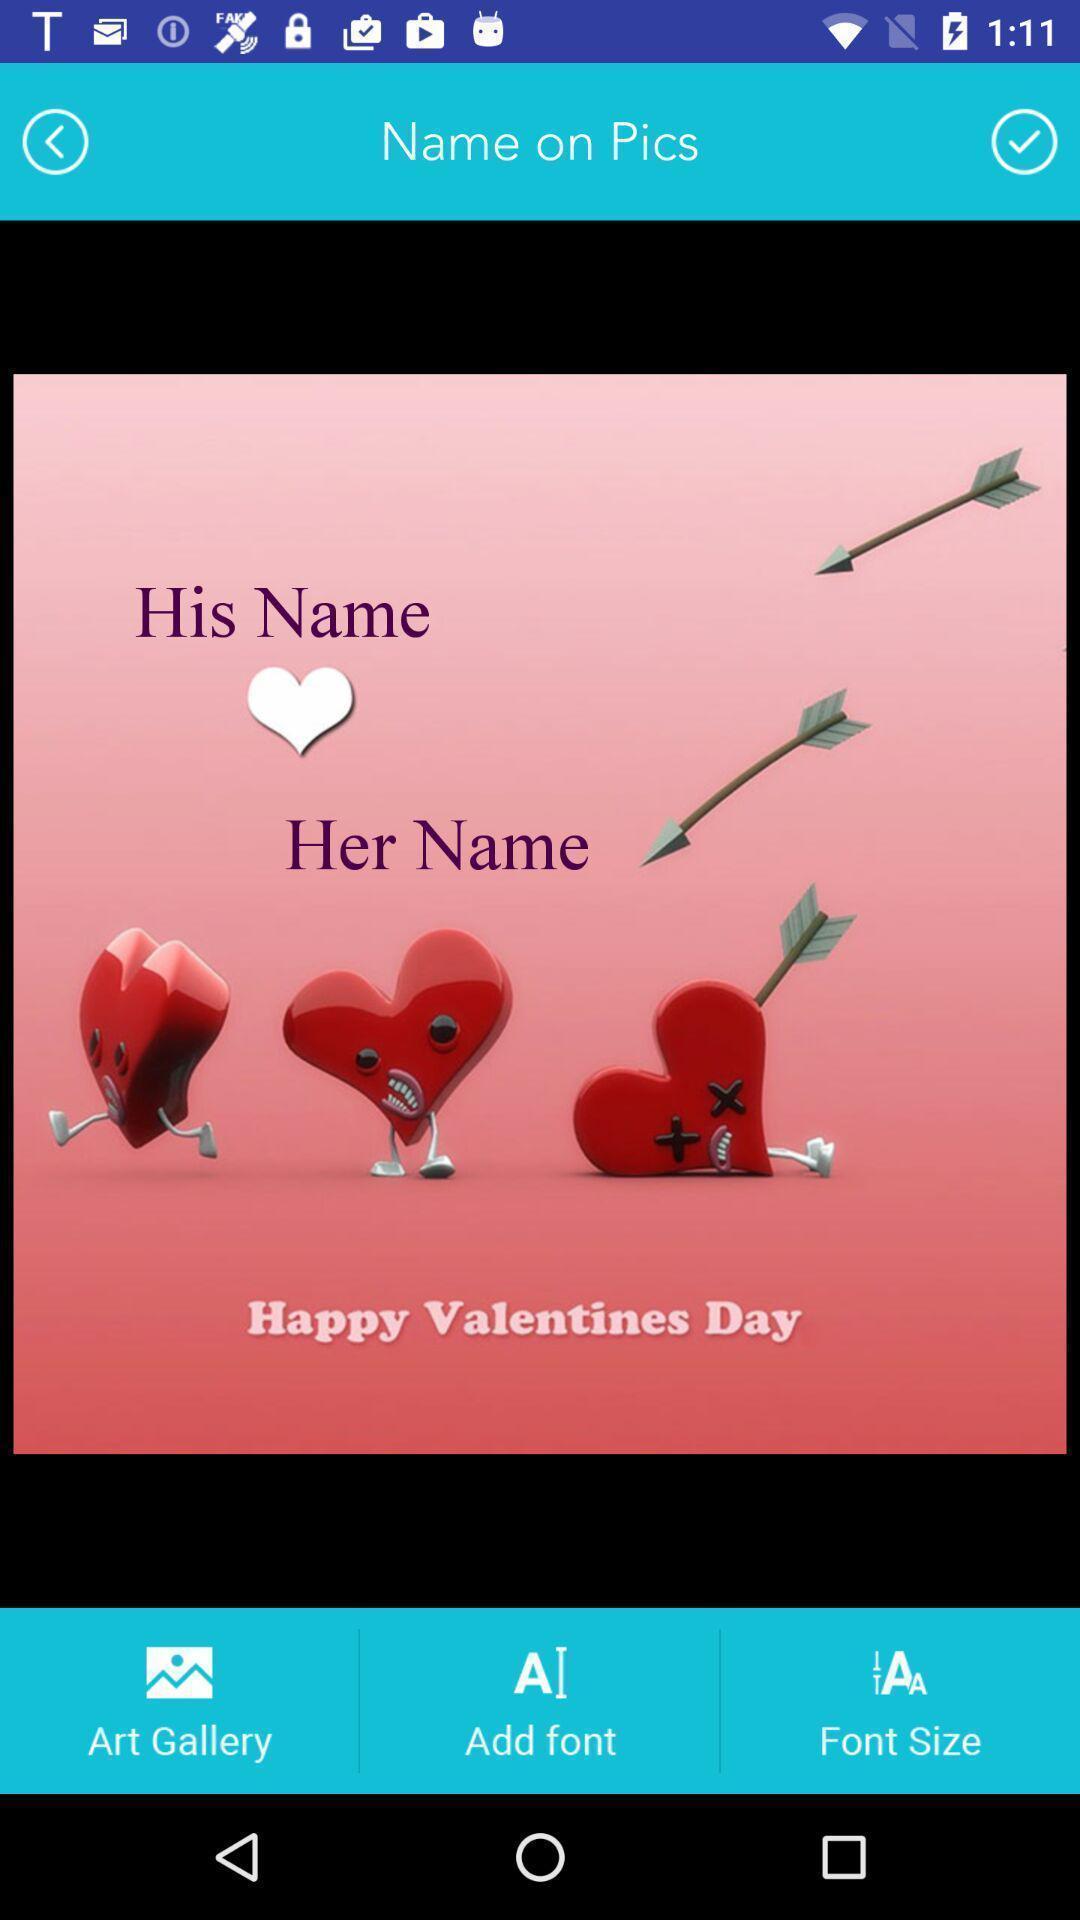Tell me what you see in this picture. Screen shows an image with multiple options. 